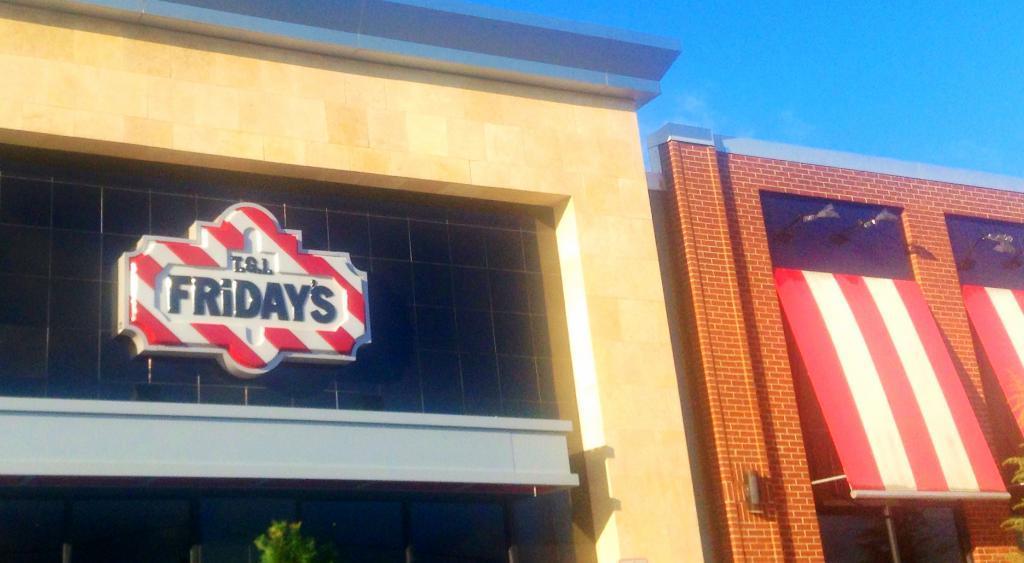Describe this image in one or two sentences. In this image in the center there are two buildings and some boards, at the bottom there are some trees. On the top of the image there is sky. 